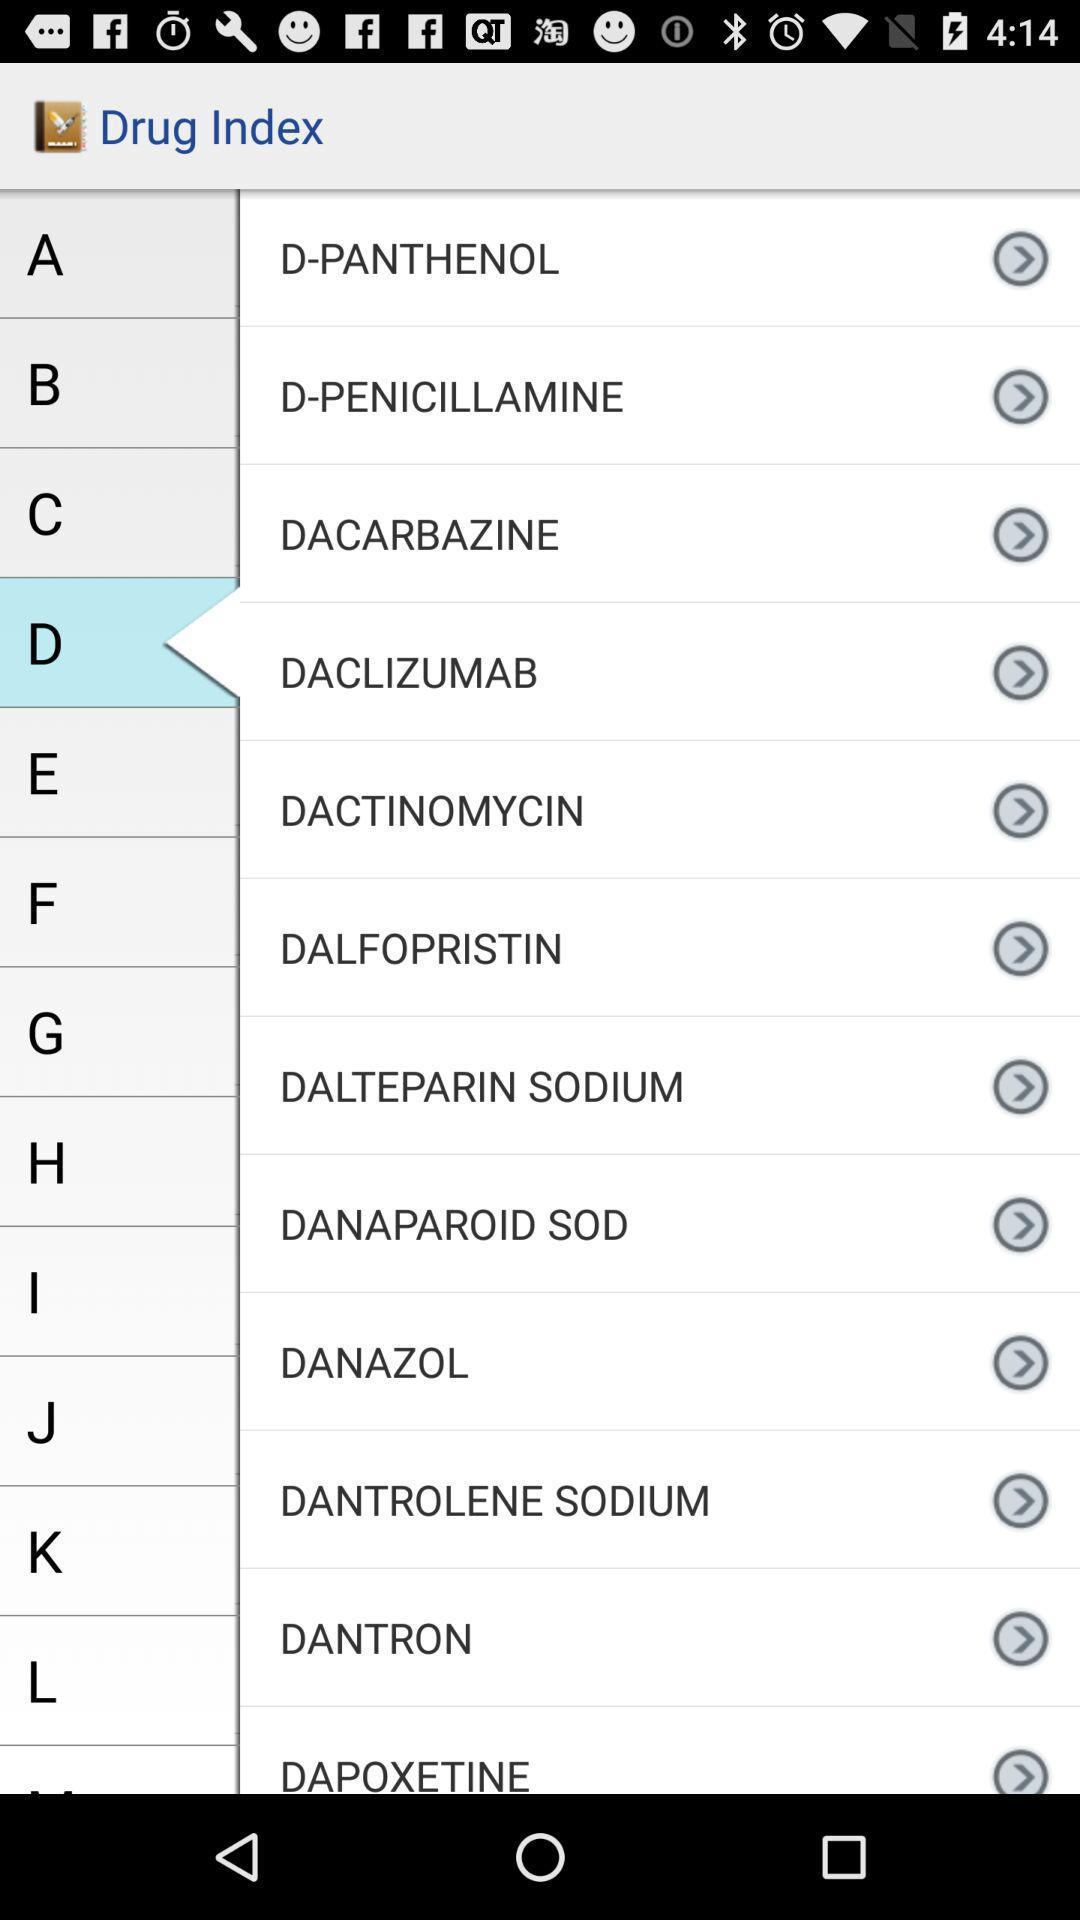What is the name of the application? The name of the application is "Drug Index". 